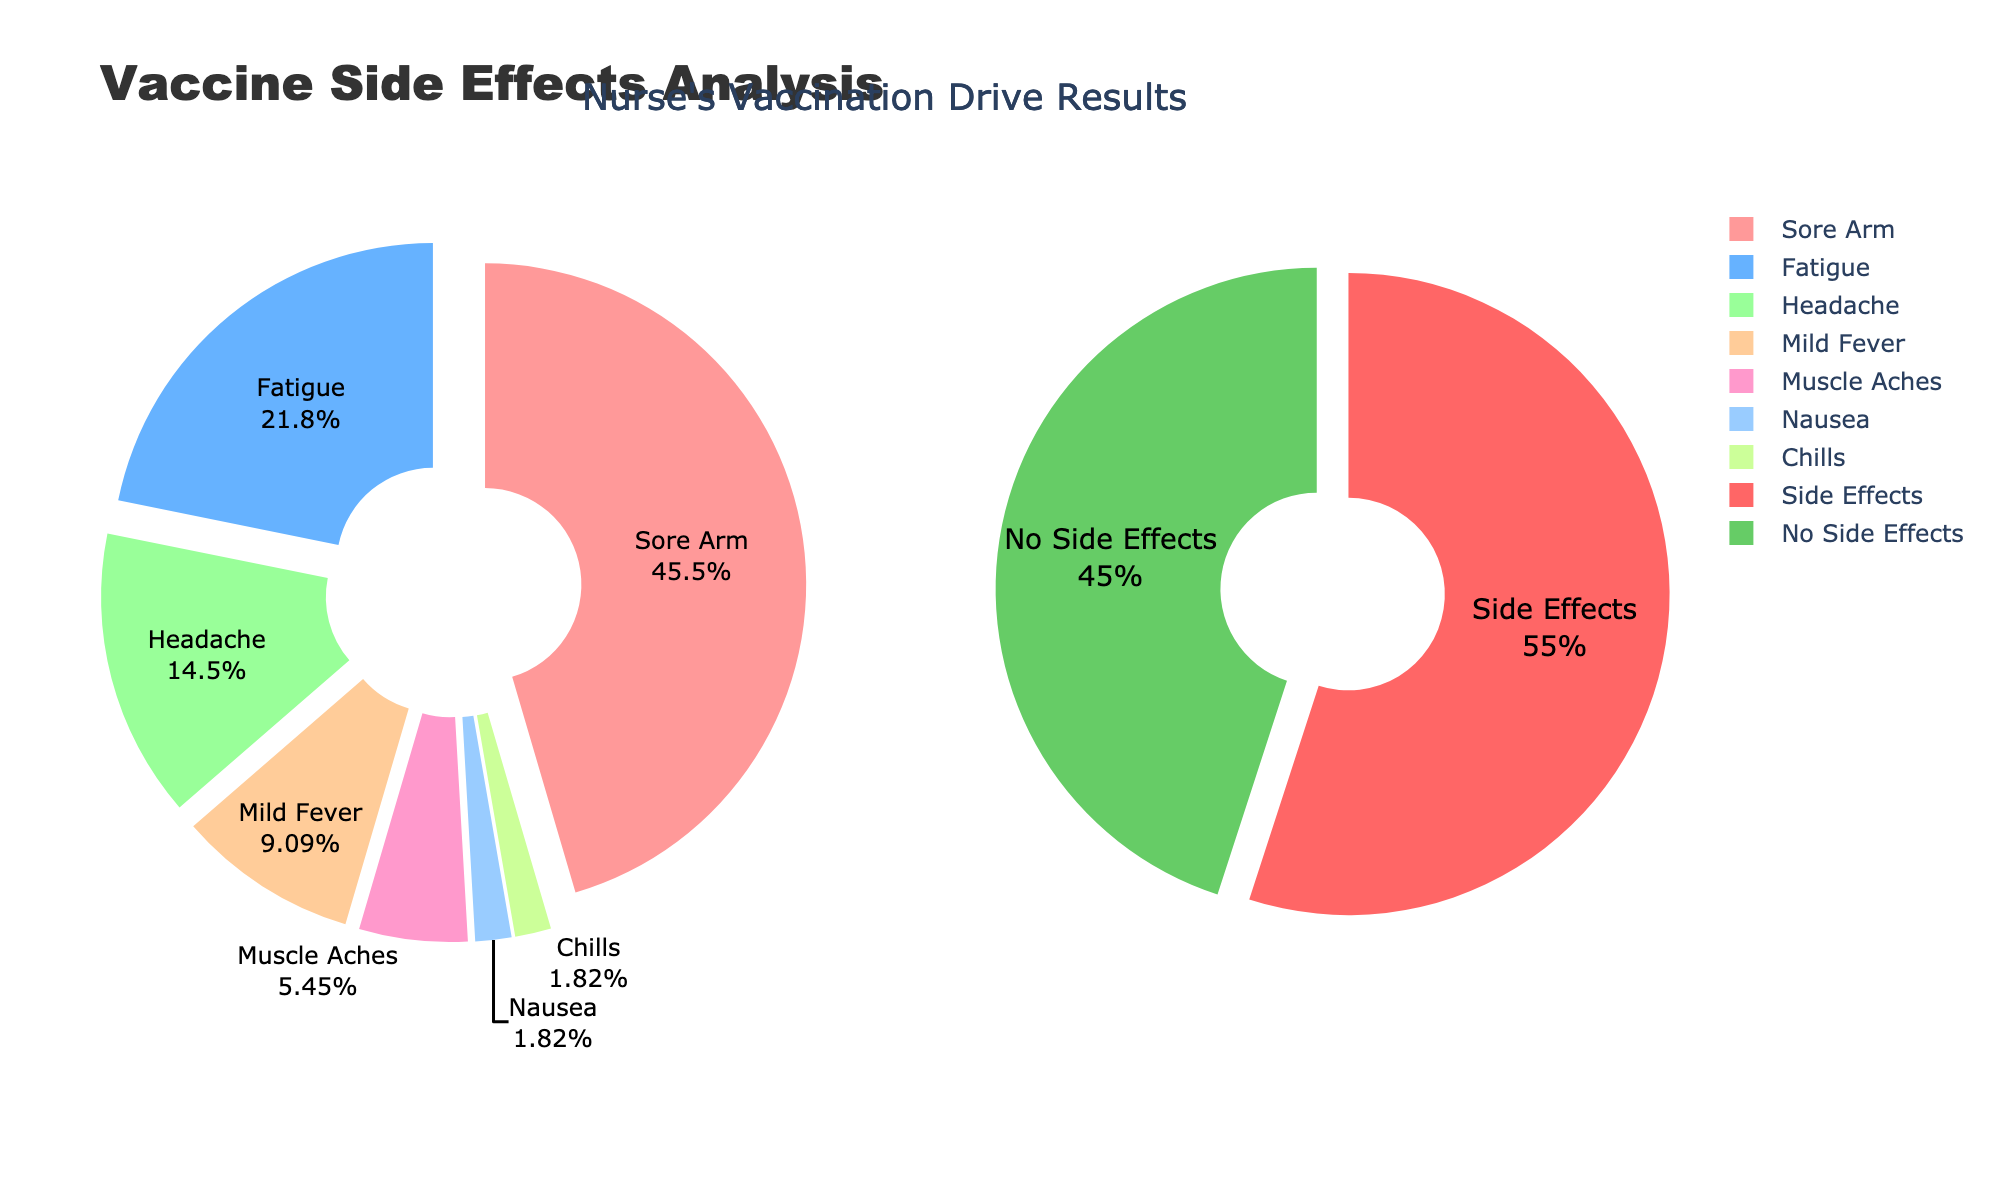What percentage of recipients reported having no side effects? The second pie chart on the right shows the distribution of recipients with and without side effects. The segment labeled "No Side Effects" indicates the percentage directly.
Answer: 45% What is the total percentage of recipients who reported side effects? The second pie chart on the right shows the distribution. The segment labeled "Side Effects" represents this percentage.
Answer: 55% Among the reported side effects, which one had the highest percentage? The first pie chart on the left shows the distribution of each specific side effect. The segment with the largest area and highest percentage value indicates the most common side effect.
Answer: Sore Arm How does the percentage of recipients who reported a "Headache" compare to those who reported "Fatigue"? Both side effects are shown in the first pie chart on the left. Compare the sizes and labeled percentages of "Headache" and "Fatigue" segments.
Answer: Fatigue is higher What is the combined percentage of recipients who reported "Muscle Aches", "Nausea", and "Chills"? Add the percentages for "Muscle Aches," "Nausea," and "Chills" from the first pie chart on the left (3%, 1%, 1%).
Answer: 5% Which color represents the "Mild Fever" in the first pie chart, and how much percentage is represented? Identify the color associated with "Mild Fever" by looking at the color coding in the first pie chart on the left and the corresponding percentage label.
Answer: Peach, 5% What fraction of the entire group experienced "Sore Arm" symptoms? The percentage of "Sore Arm" from the first pie chart on the left (25%) can be converted to a fraction by dividing by 100.
Answer: 25/100 or 1/4 Is the percentage of recipients who reported "Headache" greater than the percentage of those reporting "Muscle Aches"? Compare the percentage of "Headache" (8%) to that of "Muscle Aches" (3%) from the first pie chart on the left.
Answer: Yes How does the sum of "Fatigue" and "Headache" percentages compare to the percentage of "Sore Arm"? Add the percentages of "Fatigue" (12%) and "Headache" (8%), then compare the result with the percentage of "Sore Arm" (25%).
Answer: Lower (20% < 25%) What are the titles of the two pie charts? The titles are distinct for each sub-pie chart. They are written above each one within the figure.
Answer: "Side Effects Distribution" and "Side Effects vs No Side Effects" 